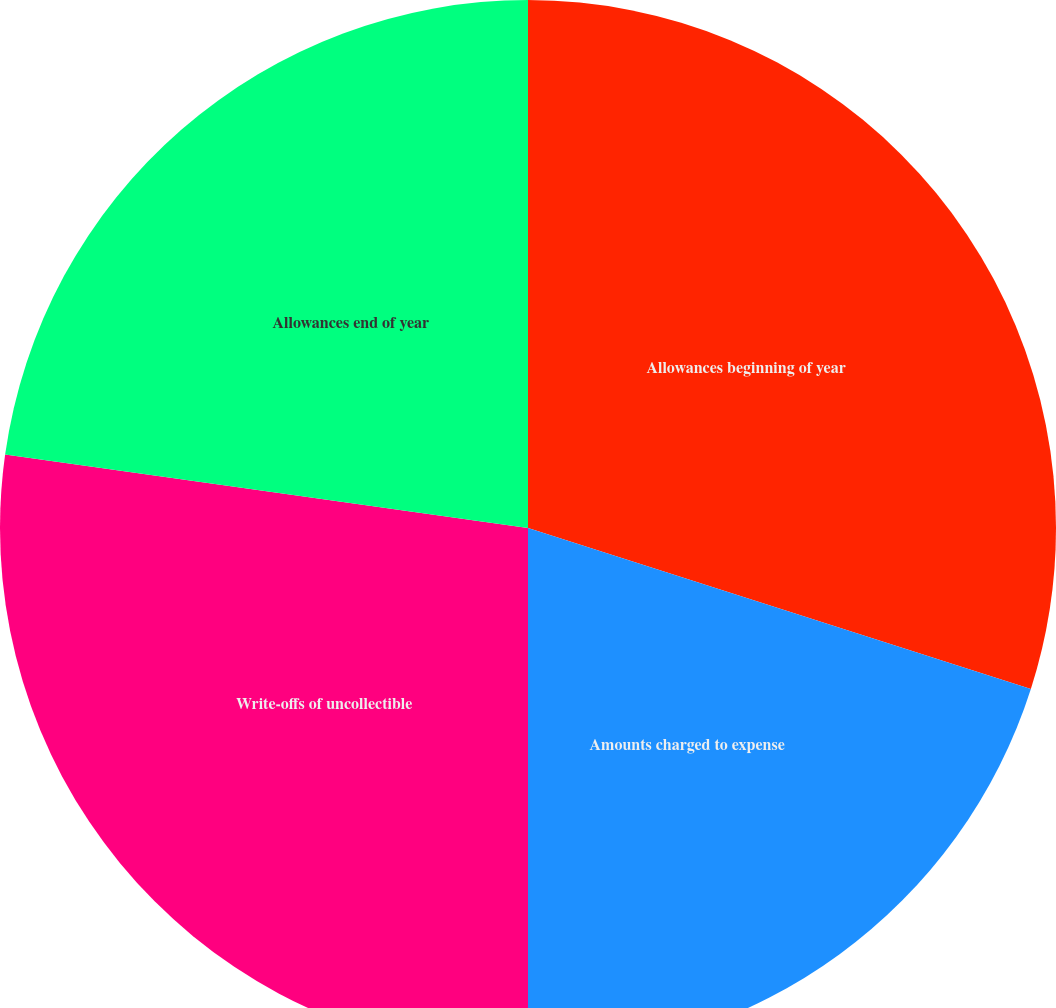Convert chart. <chart><loc_0><loc_0><loc_500><loc_500><pie_chart><fcel>Allowances beginning of year<fcel>Amounts charged to expense<fcel>Write-offs of uncollectible<fcel>Allowances end of year<nl><fcel>29.93%<fcel>20.07%<fcel>27.22%<fcel>22.78%<nl></chart> 